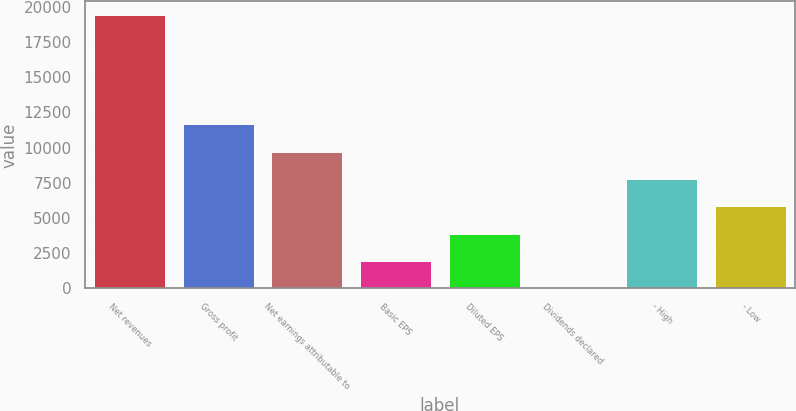Convert chart. <chart><loc_0><loc_0><loc_500><loc_500><bar_chart><fcel>Net revenues<fcel>Gross profit<fcel>Net earnings attributable to<fcel>Basic EPS<fcel>Diluted EPS<fcel>Dividends declared<fcel>- High<fcel>- Low<nl><fcel>19422<fcel>11653.6<fcel>9711.52<fcel>1943.12<fcel>3885.22<fcel>1.02<fcel>7769.42<fcel>5827.32<nl></chart> 